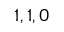<formula> <loc_0><loc_0><loc_500><loc_500>1 , 1 , 0</formula> 